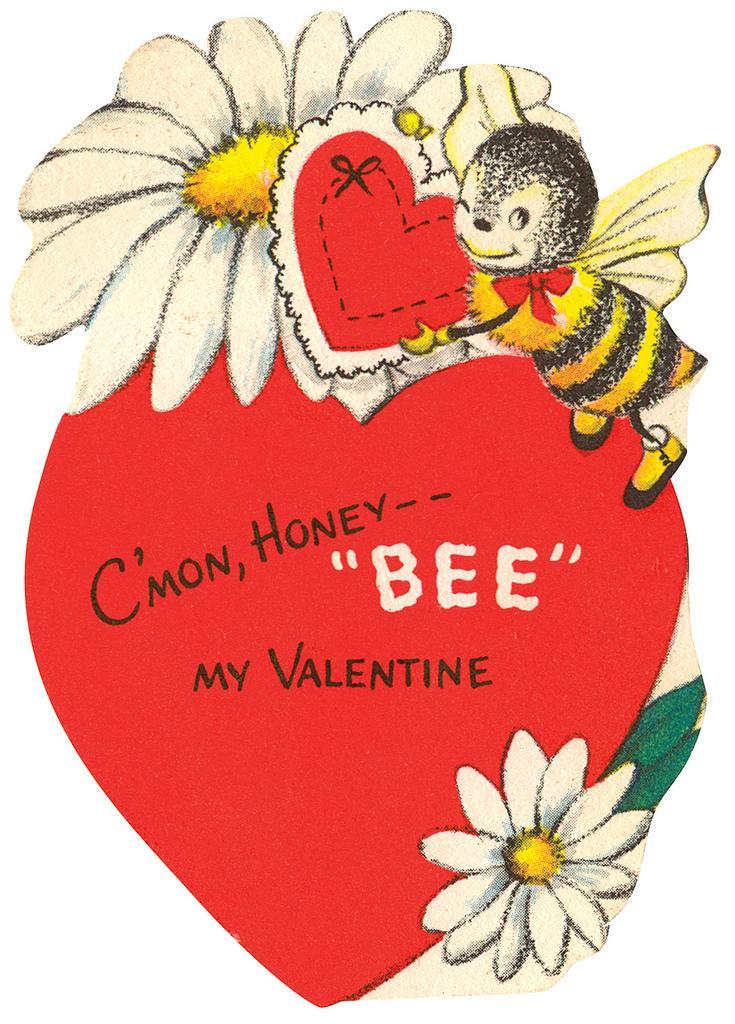Please provide a concise description of this image. In this image, we can see picture of a heart, flower and an insect. 